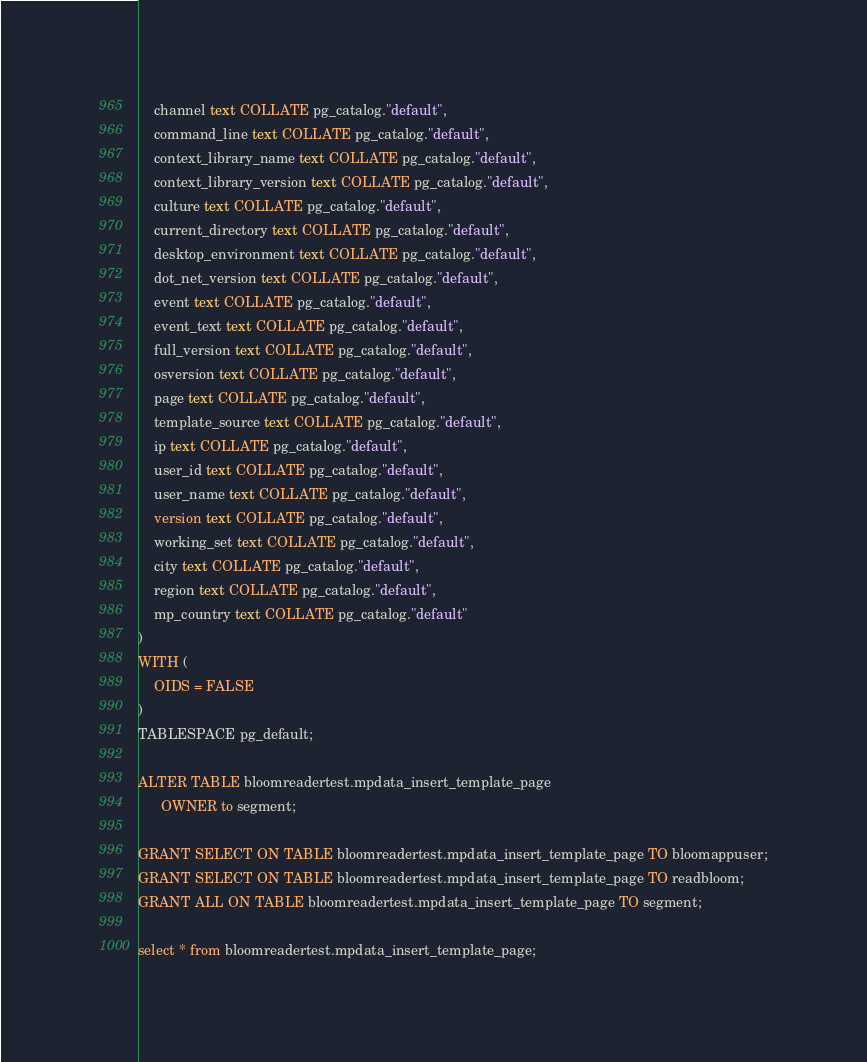Convert code to text. <code><loc_0><loc_0><loc_500><loc_500><_SQL_>    channel text COLLATE pg_catalog."default",
    command_line text COLLATE pg_catalog."default",
    context_library_name text COLLATE pg_catalog."default",
    context_library_version text COLLATE pg_catalog."default",
    culture text COLLATE pg_catalog."default",
    current_directory text COLLATE pg_catalog."default",
    desktop_environment text COLLATE pg_catalog."default",
    dot_net_version text COLLATE pg_catalog."default",
    event text COLLATE pg_catalog."default",
    event_text text COLLATE pg_catalog."default",
    full_version text COLLATE pg_catalog."default",
    osversion text COLLATE pg_catalog."default",
    page text COLLATE pg_catalog."default",
    template_source text COLLATE pg_catalog."default",
	ip text COLLATE pg_catalog."default",
    user_id text COLLATE pg_catalog."default",
    user_name text COLLATE pg_catalog."default",
    version text COLLATE pg_catalog."default",
    working_set text COLLATE pg_catalog."default",
	city text COLLATE pg_catalog."default",
    region text COLLATE pg_catalog."default",
    mp_country text COLLATE pg_catalog."default"
)
WITH (
    OIDS = FALSE
)
TABLESPACE pg_default;

ALTER TABLE bloomreadertest.mpdata_insert_template_page
	  OWNER to segment;

GRANT SELECT ON TABLE bloomreadertest.mpdata_insert_template_page TO bloomappuser;
GRANT SELECT ON TABLE bloomreadertest.mpdata_insert_template_page TO readbloom;
GRANT ALL ON TABLE bloomreadertest.mpdata_insert_template_page TO segment;
	
select * from bloomreadertest.mpdata_insert_template_page;</code> 